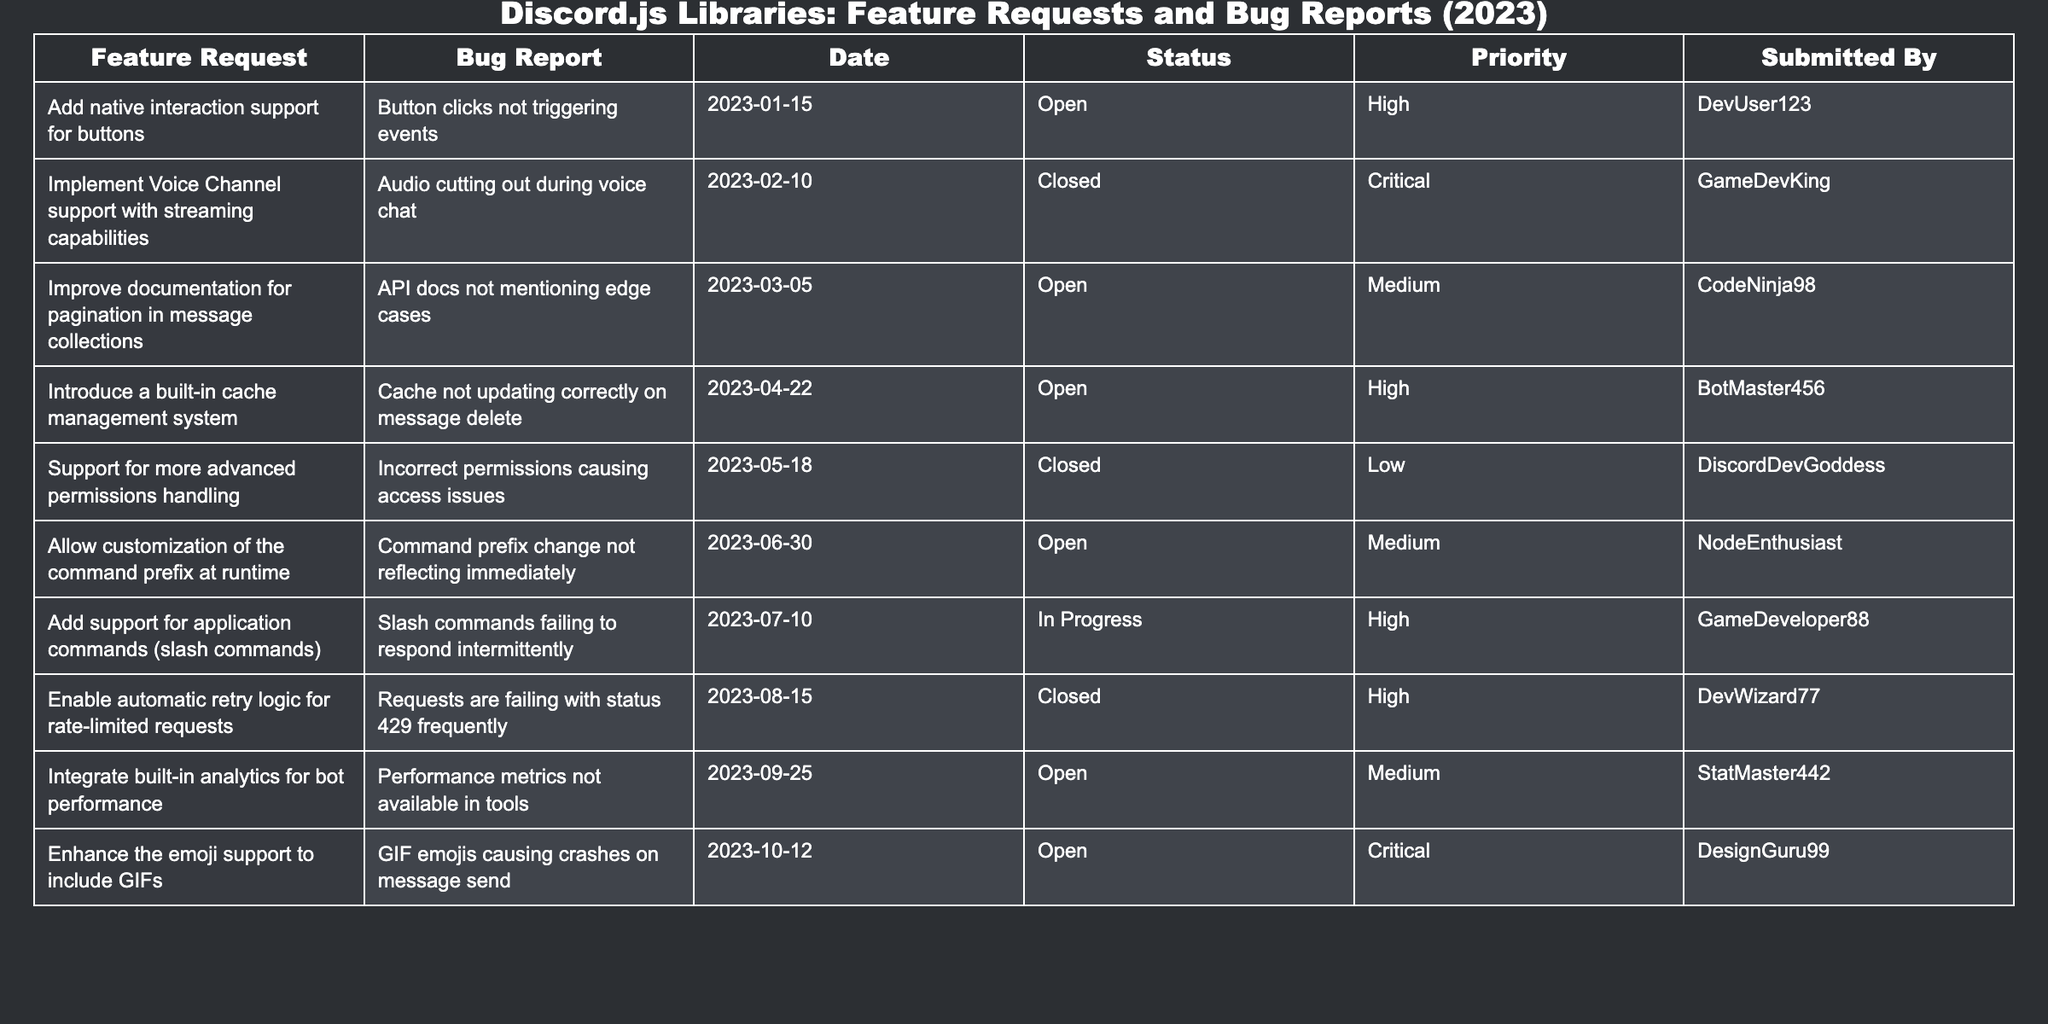What is the highest priority status for open feature requests? Looking at the "Status" and "Priority" columns, the feature request "Add native interaction support for buttons" has a priority status of "High," which is the highest available priority for items currently marked as open.
Answer: High How many bug reports are currently open? By reviewing the "Status" column, we can see there are three bug reports with a status of "Open": "Button clicks not triggering events," "Cache not updating correctly on message delete," and "GIF emojis causing crashes on message send." Therefore, the total number is 3.
Answer: 3 What is the submission date of the feature request for better documentation? The feature request to "Improve documentation for pagination in message collections" was submitted on "2023-03-05," which is noted in the "Date" column corresponding to that request.
Answer: 2023-03-05 Is there a feature request related to command customization? The table lists a feature request titled "Allow customization of the command prefix at runtime," confirming that such a request does exist.
Answer: Yes Which bug report had the highest priority and is currently closed? Examining the "Status" and "Priority" columns, the bug report "Audio cutting out during voice chat," which has a "Critical" priority, is noted as "Closed," indicating it is indeed the highest priority among closed bug reports.
Answer: Audio cutting out during voice chat How many total feature requests are submitted by DevUser123? The table shows that DevUser123 submitted only one feature request, which is "Add native interaction support for buttons," making the count one.
Answer: 1 What is the average priority level for all currently open requests? There are 5 open requests: two High, two Medium, and one Critical. The average based on assigned values (Critical: 3, High: 2, Medium: 1) is calculated as (1*3 + 2*2 + 2*1) / 5 = 2. So average priority rating is 2.
Answer: 2 What was the earliest submission date among the requests listed? By reviewing the "Date" column, the first submission date is "2023-01-15" corresponding to the feature request regarding native interaction support for buttons.
Answer: 2023-01-15 Which issue is the only one marked as "In Progress"? The request "Add support for application commands (slash commands)" is marked as "In Progress," which is the only one in that status according to the table.
Answer: Add support for application commands (slash commands) Is there any bug report that is still open and is of critical priority? Yes, the bug report "GIF emojis causing crashes on message send" has a "Critical" priority and is listed with an "Open" status, confirming it meets both criteria.
Answer: Yes 